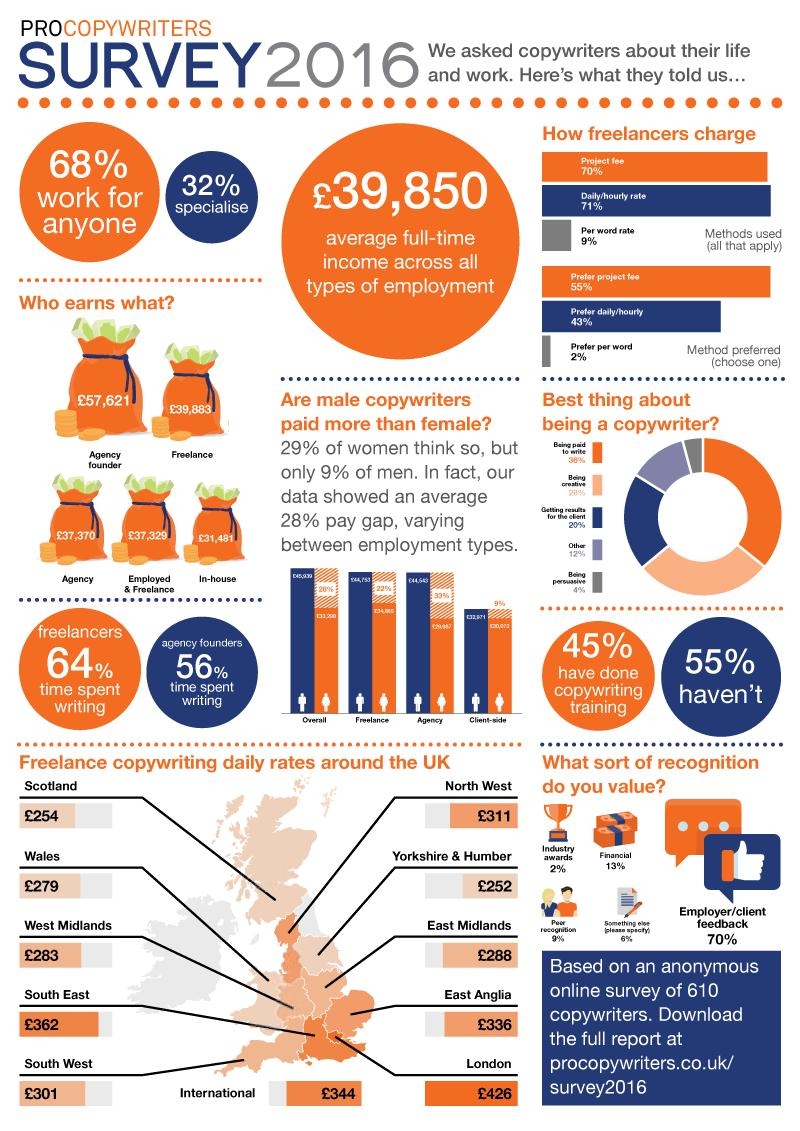Mention a couple of crucial points in this snapshot. The pay gap between men and women doing freelance work is 22%. Freelancers often use the method of charging per word rate, which typically has the lowest charge compared to other methods. Freelancers tend to prefer daily or hourly payment methods over other options when it comes to getting paid for their work. Copywriters highly value feedback from employers and clients as it is considered the most valued form of recognition. The majority of people believe that the best aspect of being a copywriter is being paid to write. 